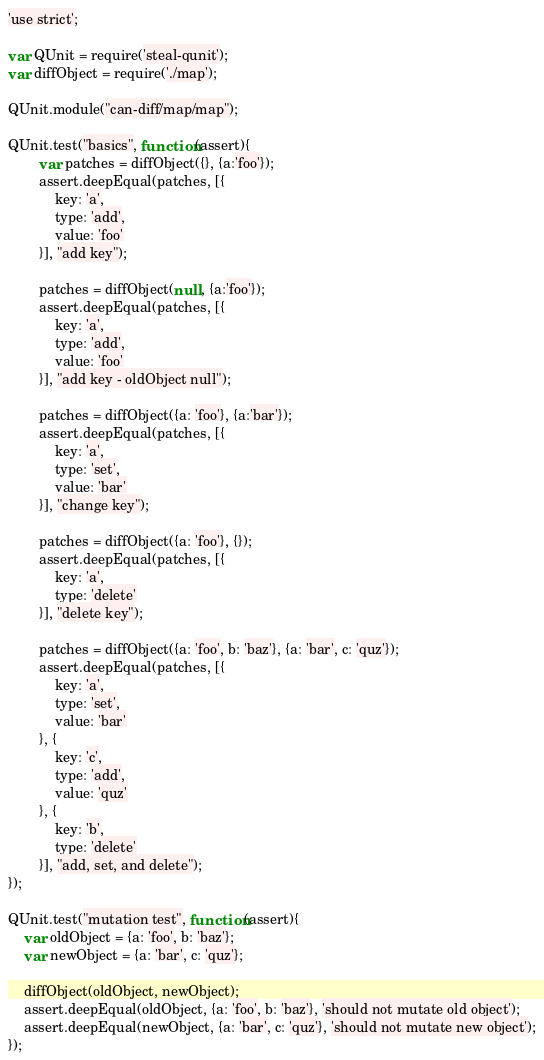Convert code to text. <code><loc_0><loc_0><loc_500><loc_500><_JavaScript_>'use strict';

var QUnit = require('steal-qunit');
var diffObject = require('./map');

QUnit.module("can-diff/map/map");

QUnit.test("basics", function(assert){
		var patches = diffObject({}, {a:'foo'});
		assert.deepEqual(patches, [{
			key: 'a',
			type: 'add',
			value: 'foo'
		}], "add key");

		patches = diffObject(null, {a:'foo'});
		assert.deepEqual(patches, [{
			key: 'a',
			type: 'add',
			value: 'foo'
		}], "add key - oldObject null");

		patches = diffObject({a: 'foo'}, {a:'bar'});
		assert.deepEqual(patches, [{
			key: 'a',
			type: 'set',
			value: 'bar'
		}], "change key");

		patches = diffObject({a: 'foo'}, {});
		assert.deepEqual(patches, [{
			key: 'a',
			type: 'delete'
		}], "delete key");

		patches = diffObject({a: 'foo', b: 'baz'}, {a: 'bar', c: 'quz'});
		assert.deepEqual(patches, [{
			key: 'a',
			type: 'set',
			value: 'bar'
		}, {
			key: 'c',
			type: 'add',
			value: 'quz'
		}, {
			key: 'b',
			type: 'delete'
		}], "add, set, and delete");
});

QUnit.test("mutation test", function(assert){
	var oldObject = {a: 'foo', b: 'baz'};
	var newObject = {a: 'bar', c: 'quz'};

	diffObject(oldObject, newObject);
	assert.deepEqual(oldObject, {a: 'foo', b: 'baz'}, 'should not mutate old object');
	assert.deepEqual(newObject, {a: 'bar', c: 'quz'}, 'should not mutate new object');
});
</code> 